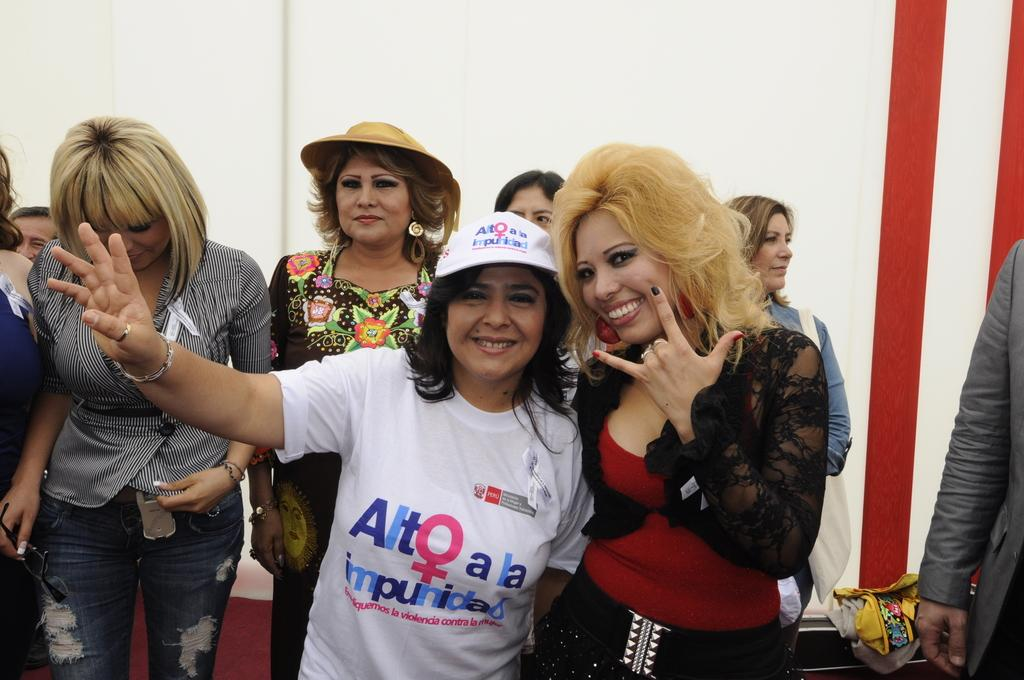What is the main subject of the image? The main subject of the image is the ladies standing in the center. What can be seen in the background of the image? There is a wall in the background of the image. Where is the person wearing a suit located in the image? The person wearing a suit is on the right side of the image. How many eggs are visible in the image? There are no eggs present in the image. What type of process is being carried out by the ladies in the image? The provided facts do not mention any specific process being carried out by the ladies in the image. 